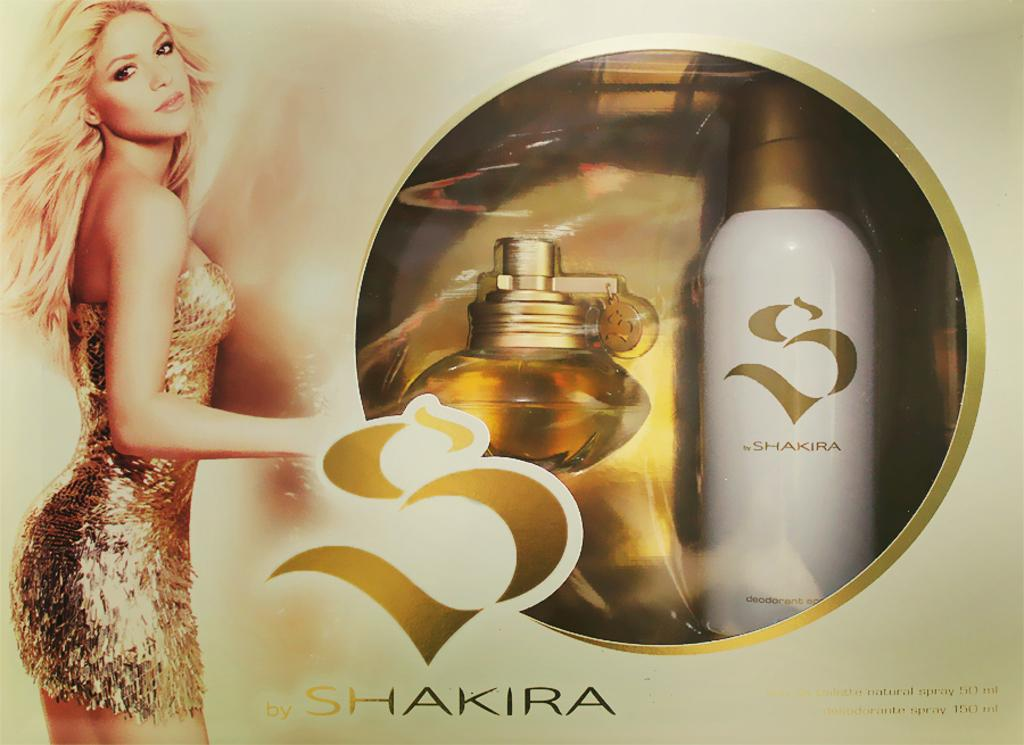<image>
Create a compact narrative representing the image presented. A blonde woman imposed on a package that reads, "Shakira." 